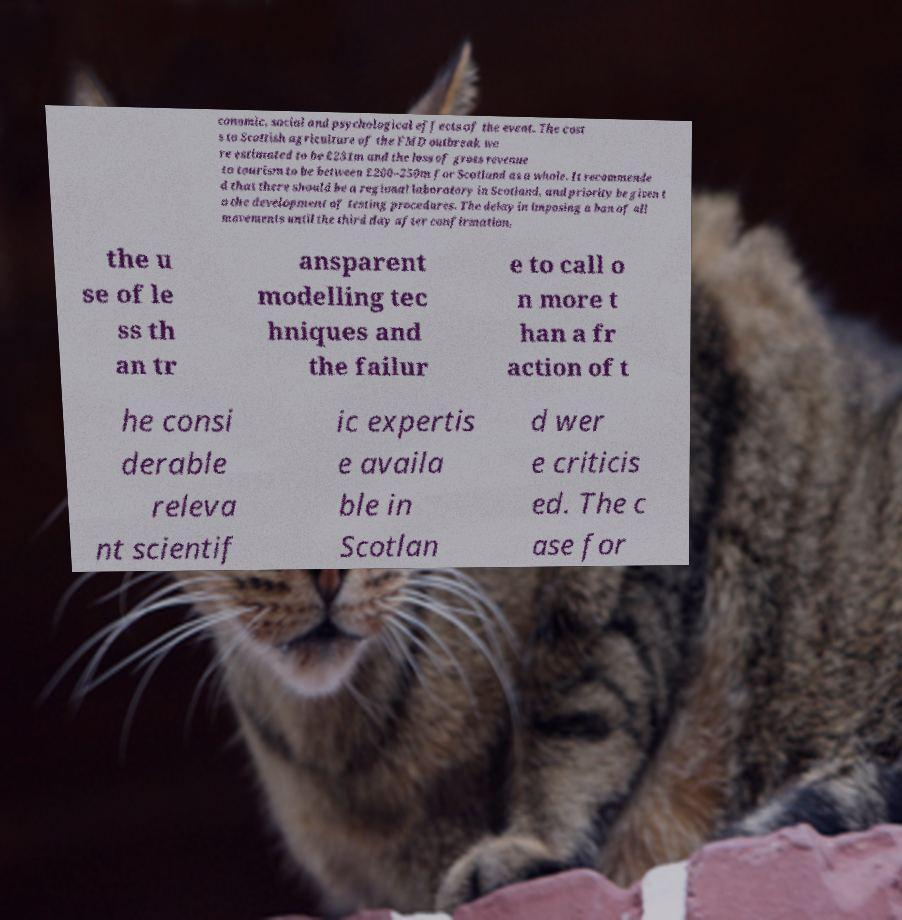I need the written content from this picture converted into text. Can you do that? conomic, social and psychological effects of the event. The cost s to Scottish agriculture of the FMD outbreak we re estimated to be £231m and the loss of gross revenue to tourism to be between £200–250m for Scotland as a whole. It recommende d that there should be a regional laboratory in Scotland, and priority be given t o the development of testing procedures. The delay in imposing a ban of all movements until the third day after confirmation, the u se of le ss th an tr ansparent modelling tec hniques and the failur e to call o n more t han a fr action of t he consi derable releva nt scientif ic expertis e availa ble in Scotlan d wer e criticis ed. The c ase for 